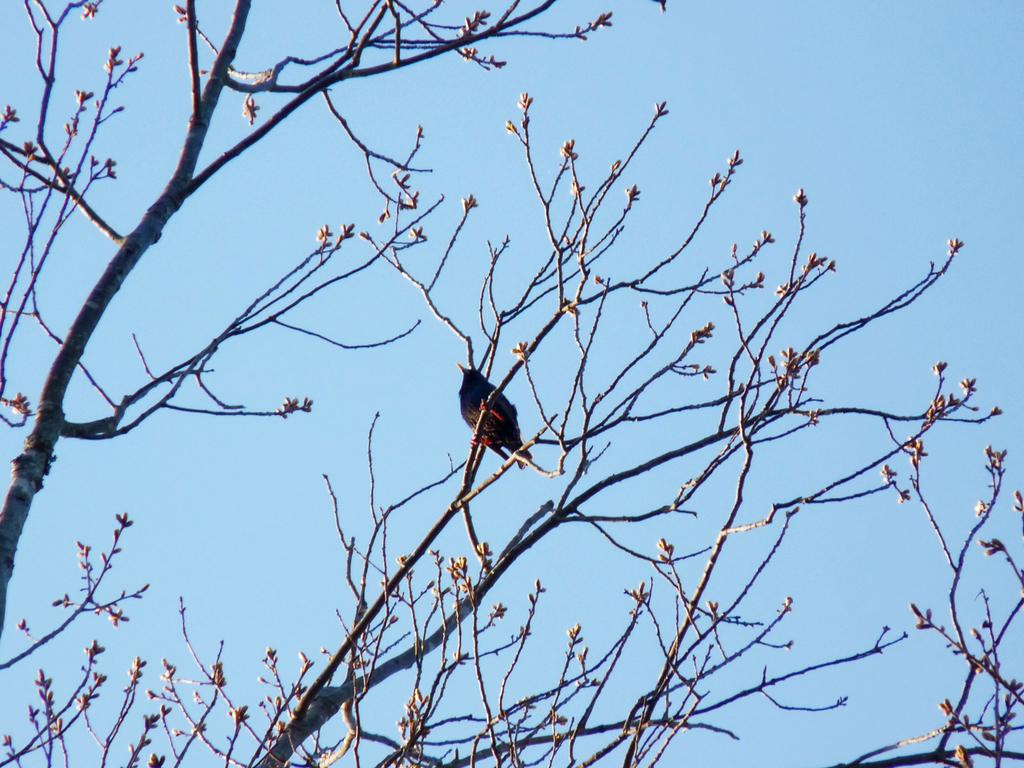What type of animal can be seen in the image? There is a bird in the image. Where is the bird located in the image? The bird is sitting on the branches of a tree. Can you describe the tree in the image? The tree has small branches. What is visible in the background of the image? The sky is visible in the image. What book is the bird reading in the image? There is no book present in the image, as it features a bird sitting on the branches of a tree. 